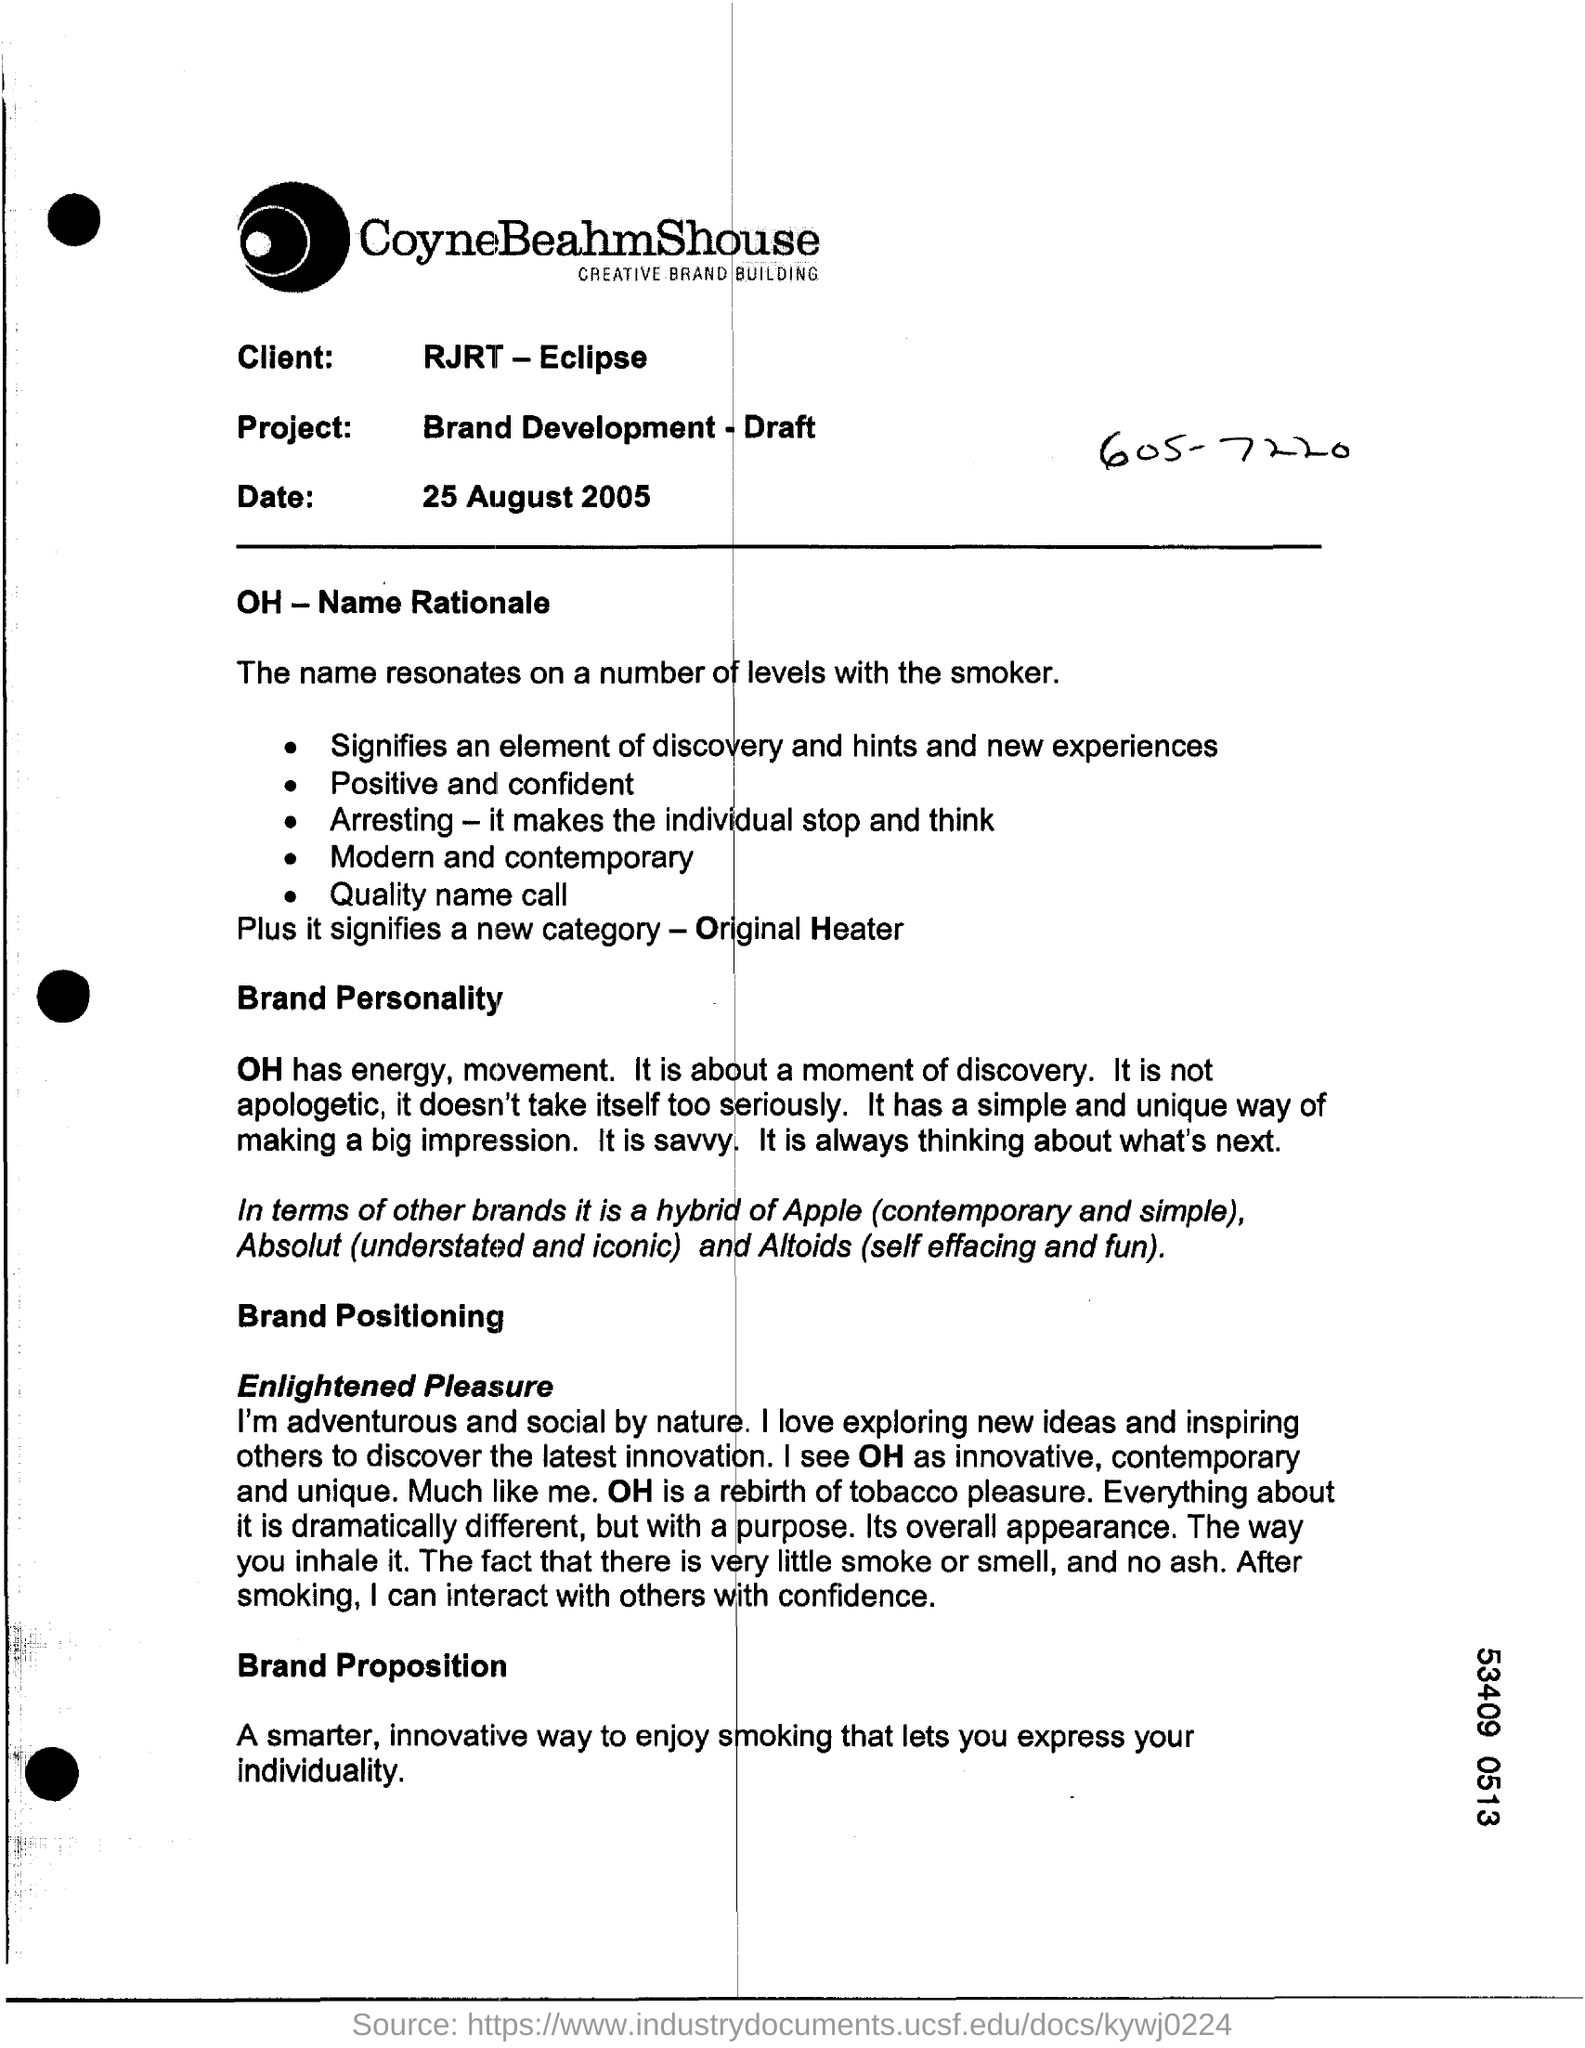What is the client name?
Offer a terse response. RJRT- Eclipse. What is the project name?
Offer a terse response. Brand development -draft. 